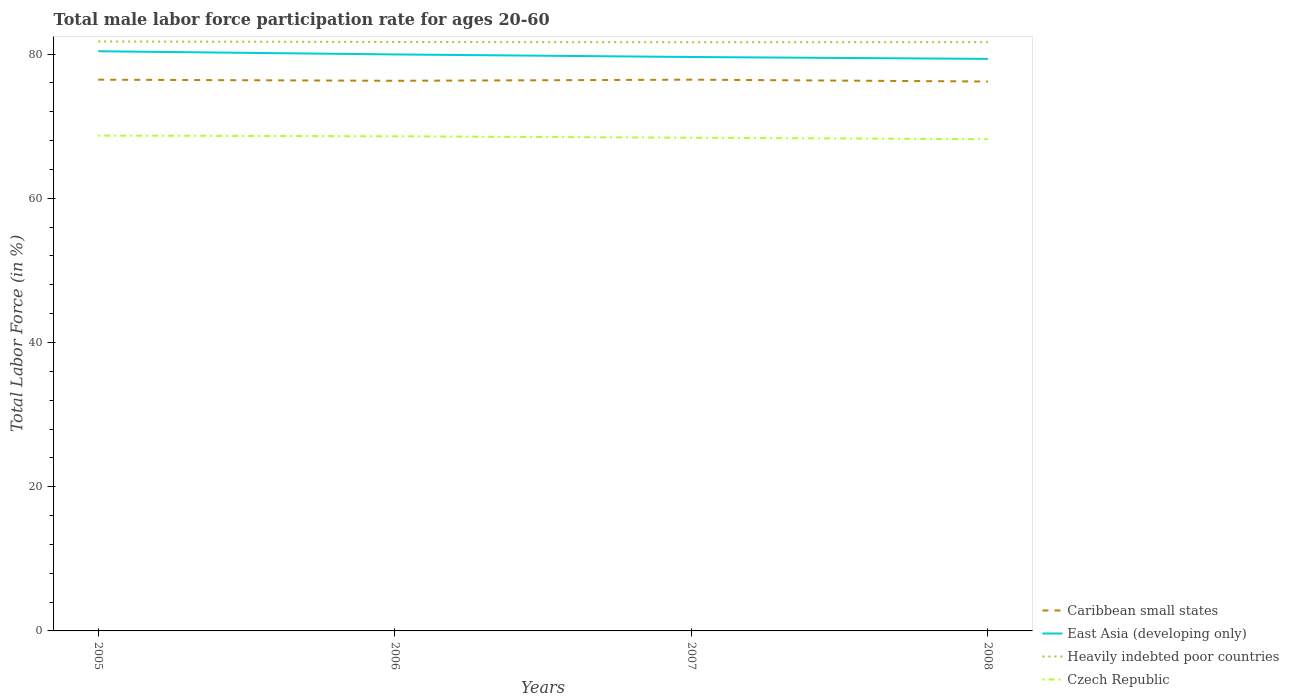How many different coloured lines are there?
Your answer should be compact. 4. Across all years, what is the maximum male labor force participation rate in Czech Republic?
Make the answer very short. 68.2. What is the total male labor force participation rate in Czech Republic in the graph?
Keep it short and to the point. 0.1. What is the difference between the highest and the second highest male labor force participation rate in Caribbean small states?
Offer a terse response. 0.25. Is the male labor force participation rate in Heavily indebted poor countries strictly greater than the male labor force participation rate in East Asia (developing only) over the years?
Ensure brevity in your answer.  No. How many years are there in the graph?
Give a very brief answer. 4. Does the graph contain grids?
Provide a succinct answer. No. Where does the legend appear in the graph?
Your answer should be very brief. Bottom right. What is the title of the graph?
Your response must be concise. Total male labor force participation rate for ages 20-60. What is the label or title of the X-axis?
Provide a succinct answer. Years. What is the label or title of the Y-axis?
Offer a very short reply. Total Labor Force (in %). What is the Total Labor Force (in %) of Caribbean small states in 2005?
Your answer should be compact. 76.45. What is the Total Labor Force (in %) in East Asia (developing only) in 2005?
Give a very brief answer. 80.39. What is the Total Labor Force (in %) in Heavily indebted poor countries in 2005?
Your response must be concise. 81.75. What is the Total Labor Force (in %) of Czech Republic in 2005?
Keep it short and to the point. 68.7. What is the Total Labor Force (in %) in Caribbean small states in 2006?
Your response must be concise. 76.3. What is the Total Labor Force (in %) in East Asia (developing only) in 2006?
Provide a succinct answer. 79.95. What is the Total Labor Force (in %) in Heavily indebted poor countries in 2006?
Your response must be concise. 81.68. What is the Total Labor Force (in %) of Czech Republic in 2006?
Your response must be concise. 68.6. What is the Total Labor Force (in %) of Caribbean small states in 2007?
Offer a very short reply. 76.45. What is the Total Labor Force (in %) of East Asia (developing only) in 2007?
Provide a succinct answer. 79.6. What is the Total Labor Force (in %) in Heavily indebted poor countries in 2007?
Provide a short and direct response. 81.65. What is the Total Labor Force (in %) of Czech Republic in 2007?
Your answer should be very brief. 68.4. What is the Total Labor Force (in %) of Caribbean small states in 2008?
Your answer should be compact. 76.2. What is the Total Labor Force (in %) of East Asia (developing only) in 2008?
Provide a succinct answer. 79.34. What is the Total Labor Force (in %) in Heavily indebted poor countries in 2008?
Provide a short and direct response. 81.66. What is the Total Labor Force (in %) in Czech Republic in 2008?
Offer a terse response. 68.2. Across all years, what is the maximum Total Labor Force (in %) of Caribbean small states?
Your response must be concise. 76.45. Across all years, what is the maximum Total Labor Force (in %) of East Asia (developing only)?
Keep it short and to the point. 80.39. Across all years, what is the maximum Total Labor Force (in %) in Heavily indebted poor countries?
Make the answer very short. 81.75. Across all years, what is the maximum Total Labor Force (in %) in Czech Republic?
Give a very brief answer. 68.7. Across all years, what is the minimum Total Labor Force (in %) of Caribbean small states?
Your answer should be compact. 76.2. Across all years, what is the minimum Total Labor Force (in %) of East Asia (developing only)?
Offer a very short reply. 79.34. Across all years, what is the minimum Total Labor Force (in %) of Heavily indebted poor countries?
Your response must be concise. 81.65. Across all years, what is the minimum Total Labor Force (in %) of Czech Republic?
Offer a very short reply. 68.2. What is the total Total Labor Force (in %) in Caribbean small states in the graph?
Your answer should be compact. 305.39. What is the total Total Labor Force (in %) of East Asia (developing only) in the graph?
Ensure brevity in your answer.  319.28. What is the total Total Labor Force (in %) of Heavily indebted poor countries in the graph?
Offer a terse response. 326.74. What is the total Total Labor Force (in %) in Czech Republic in the graph?
Keep it short and to the point. 273.9. What is the difference between the Total Labor Force (in %) in Caribbean small states in 2005 and that in 2006?
Give a very brief answer. 0.15. What is the difference between the Total Labor Force (in %) in East Asia (developing only) in 2005 and that in 2006?
Offer a very short reply. 0.44. What is the difference between the Total Labor Force (in %) in Heavily indebted poor countries in 2005 and that in 2006?
Keep it short and to the point. 0.07. What is the difference between the Total Labor Force (in %) of Czech Republic in 2005 and that in 2006?
Provide a succinct answer. 0.1. What is the difference between the Total Labor Force (in %) in Caribbean small states in 2005 and that in 2007?
Your answer should be very brief. -0. What is the difference between the Total Labor Force (in %) in East Asia (developing only) in 2005 and that in 2007?
Your answer should be compact. 0.8. What is the difference between the Total Labor Force (in %) of Heavily indebted poor countries in 2005 and that in 2007?
Your response must be concise. 0.1. What is the difference between the Total Labor Force (in %) of Czech Republic in 2005 and that in 2007?
Offer a terse response. 0.3. What is the difference between the Total Labor Force (in %) of Caribbean small states in 2005 and that in 2008?
Your response must be concise. 0.25. What is the difference between the Total Labor Force (in %) of East Asia (developing only) in 2005 and that in 2008?
Keep it short and to the point. 1.06. What is the difference between the Total Labor Force (in %) of Heavily indebted poor countries in 2005 and that in 2008?
Provide a short and direct response. 0.09. What is the difference between the Total Labor Force (in %) of Caribbean small states in 2006 and that in 2007?
Make the answer very short. -0.15. What is the difference between the Total Labor Force (in %) of East Asia (developing only) in 2006 and that in 2007?
Offer a very short reply. 0.36. What is the difference between the Total Labor Force (in %) of Heavily indebted poor countries in 2006 and that in 2007?
Your answer should be compact. 0.03. What is the difference between the Total Labor Force (in %) in Czech Republic in 2006 and that in 2007?
Provide a succinct answer. 0.2. What is the difference between the Total Labor Force (in %) of Caribbean small states in 2006 and that in 2008?
Provide a succinct answer. 0.1. What is the difference between the Total Labor Force (in %) in East Asia (developing only) in 2006 and that in 2008?
Offer a terse response. 0.62. What is the difference between the Total Labor Force (in %) of Heavily indebted poor countries in 2006 and that in 2008?
Provide a succinct answer. 0.01. What is the difference between the Total Labor Force (in %) of Czech Republic in 2006 and that in 2008?
Your response must be concise. 0.4. What is the difference between the Total Labor Force (in %) of Caribbean small states in 2007 and that in 2008?
Keep it short and to the point. 0.25. What is the difference between the Total Labor Force (in %) of East Asia (developing only) in 2007 and that in 2008?
Offer a very short reply. 0.26. What is the difference between the Total Labor Force (in %) of Heavily indebted poor countries in 2007 and that in 2008?
Keep it short and to the point. -0.02. What is the difference between the Total Labor Force (in %) of Caribbean small states in 2005 and the Total Labor Force (in %) of East Asia (developing only) in 2006?
Your response must be concise. -3.5. What is the difference between the Total Labor Force (in %) of Caribbean small states in 2005 and the Total Labor Force (in %) of Heavily indebted poor countries in 2006?
Your answer should be very brief. -5.23. What is the difference between the Total Labor Force (in %) of Caribbean small states in 2005 and the Total Labor Force (in %) of Czech Republic in 2006?
Ensure brevity in your answer.  7.85. What is the difference between the Total Labor Force (in %) of East Asia (developing only) in 2005 and the Total Labor Force (in %) of Heavily indebted poor countries in 2006?
Ensure brevity in your answer.  -1.28. What is the difference between the Total Labor Force (in %) in East Asia (developing only) in 2005 and the Total Labor Force (in %) in Czech Republic in 2006?
Provide a short and direct response. 11.79. What is the difference between the Total Labor Force (in %) in Heavily indebted poor countries in 2005 and the Total Labor Force (in %) in Czech Republic in 2006?
Your answer should be very brief. 13.15. What is the difference between the Total Labor Force (in %) of Caribbean small states in 2005 and the Total Labor Force (in %) of East Asia (developing only) in 2007?
Your answer should be compact. -3.15. What is the difference between the Total Labor Force (in %) of Caribbean small states in 2005 and the Total Labor Force (in %) of Heavily indebted poor countries in 2007?
Provide a succinct answer. -5.2. What is the difference between the Total Labor Force (in %) in Caribbean small states in 2005 and the Total Labor Force (in %) in Czech Republic in 2007?
Offer a terse response. 8.05. What is the difference between the Total Labor Force (in %) of East Asia (developing only) in 2005 and the Total Labor Force (in %) of Heavily indebted poor countries in 2007?
Offer a very short reply. -1.25. What is the difference between the Total Labor Force (in %) of East Asia (developing only) in 2005 and the Total Labor Force (in %) of Czech Republic in 2007?
Keep it short and to the point. 11.99. What is the difference between the Total Labor Force (in %) in Heavily indebted poor countries in 2005 and the Total Labor Force (in %) in Czech Republic in 2007?
Provide a short and direct response. 13.35. What is the difference between the Total Labor Force (in %) in Caribbean small states in 2005 and the Total Labor Force (in %) in East Asia (developing only) in 2008?
Your answer should be very brief. -2.89. What is the difference between the Total Labor Force (in %) in Caribbean small states in 2005 and the Total Labor Force (in %) in Heavily indebted poor countries in 2008?
Offer a very short reply. -5.21. What is the difference between the Total Labor Force (in %) in Caribbean small states in 2005 and the Total Labor Force (in %) in Czech Republic in 2008?
Offer a terse response. 8.25. What is the difference between the Total Labor Force (in %) in East Asia (developing only) in 2005 and the Total Labor Force (in %) in Heavily indebted poor countries in 2008?
Provide a succinct answer. -1.27. What is the difference between the Total Labor Force (in %) in East Asia (developing only) in 2005 and the Total Labor Force (in %) in Czech Republic in 2008?
Provide a short and direct response. 12.19. What is the difference between the Total Labor Force (in %) of Heavily indebted poor countries in 2005 and the Total Labor Force (in %) of Czech Republic in 2008?
Offer a terse response. 13.55. What is the difference between the Total Labor Force (in %) in Caribbean small states in 2006 and the Total Labor Force (in %) in East Asia (developing only) in 2007?
Make the answer very short. -3.3. What is the difference between the Total Labor Force (in %) of Caribbean small states in 2006 and the Total Labor Force (in %) of Heavily indebted poor countries in 2007?
Give a very brief answer. -5.35. What is the difference between the Total Labor Force (in %) in Caribbean small states in 2006 and the Total Labor Force (in %) in Czech Republic in 2007?
Ensure brevity in your answer.  7.9. What is the difference between the Total Labor Force (in %) in East Asia (developing only) in 2006 and the Total Labor Force (in %) in Heavily indebted poor countries in 2007?
Give a very brief answer. -1.7. What is the difference between the Total Labor Force (in %) in East Asia (developing only) in 2006 and the Total Labor Force (in %) in Czech Republic in 2007?
Give a very brief answer. 11.55. What is the difference between the Total Labor Force (in %) in Heavily indebted poor countries in 2006 and the Total Labor Force (in %) in Czech Republic in 2007?
Your answer should be compact. 13.28. What is the difference between the Total Labor Force (in %) in Caribbean small states in 2006 and the Total Labor Force (in %) in East Asia (developing only) in 2008?
Make the answer very short. -3.04. What is the difference between the Total Labor Force (in %) in Caribbean small states in 2006 and the Total Labor Force (in %) in Heavily indebted poor countries in 2008?
Your answer should be compact. -5.37. What is the difference between the Total Labor Force (in %) in Caribbean small states in 2006 and the Total Labor Force (in %) in Czech Republic in 2008?
Offer a very short reply. 8.1. What is the difference between the Total Labor Force (in %) of East Asia (developing only) in 2006 and the Total Labor Force (in %) of Heavily indebted poor countries in 2008?
Your answer should be very brief. -1.71. What is the difference between the Total Labor Force (in %) in East Asia (developing only) in 2006 and the Total Labor Force (in %) in Czech Republic in 2008?
Provide a short and direct response. 11.75. What is the difference between the Total Labor Force (in %) in Heavily indebted poor countries in 2006 and the Total Labor Force (in %) in Czech Republic in 2008?
Provide a short and direct response. 13.48. What is the difference between the Total Labor Force (in %) of Caribbean small states in 2007 and the Total Labor Force (in %) of East Asia (developing only) in 2008?
Make the answer very short. -2.88. What is the difference between the Total Labor Force (in %) in Caribbean small states in 2007 and the Total Labor Force (in %) in Heavily indebted poor countries in 2008?
Your response must be concise. -5.21. What is the difference between the Total Labor Force (in %) of Caribbean small states in 2007 and the Total Labor Force (in %) of Czech Republic in 2008?
Your answer should be very brief. 8.25. What is the difference between the Total Labor Force (in %) in East Asia (developing only) in 2007 and the Total Labor Force (in %) in Heavily indebted poor countries in 2008?
Make the answer very short. -2.07. What is the difference between the Total Labor Force (in %) of East Asia (developing only) in 2007 and the Total Labor Force (in %) of Czech Republic in 2008?
Your answer should be very brief. 11.4. What is the difference between the Total Labor Force (in %) of Heavily indebted poor countries in 2007 and the Total Labor Force (in %) of Czech Republic in 2008?
Your answer should be very brief. 13.45. What is the average Total Labor Force (in %) in Caribbean small states per year?
Ensure brevity in your answer.  76.35. What is the average Total Labor Force (in %) of East Asia (developing only) per year?
Your answer should be compact. 79.82. What is the average Total Labor Force (in %) of Heavily indebted poor countries per year?
Your response must be concise. 81.69. What is the average Total Labor Force (in %) in Czech Republic per year?
Provide a succinct answer. 68.47. In the year 2005, what is the difference between the Total Labor Force (in %) in Caribbean small states and Total Labor Force (in %) in East Asia (developing only)?
Offer a terse response. -3.94. In the year 2005, what is the difference between the Total Labor Force (in %) in Caribbean small states and Total Labor Force (in %) in Heavily indebted poor countries?
Your response must be concise. -5.3. In the year 2005, what is the difference between the Total Labor Force (in %) of Caribbean small states and Total Labor Force (in %) of Czech Republic?
Offer a terse response. 7.75. In the year 2005, what is the difference between the Total Labor Force (in %) in East Asia (developing only) and Total Labor Force (in %) in Heavily indebted poor countries?
Offer a very short reply. -1.36. In the year 2005, what is the difference between the Total Labor Force (in %) in East Asia (developing only) and Total Labor Force (in %) in Czech Republic?
Provide a short and direct response. 11.69. In the year 2005, what is the difference between the Total Labor Force (in %) of Heavily indebted poor countries and Total Labor Force (in %) of Czech Republic?
Your response must be concise. 13.05. In the year 2006, what is the difference between the Total Labor Force (in %) in Caribbean small states and Total Labor Force (in %) in East Asia (developing only)?
Give a very brief answer. -3.66. In the year 2006, what is the difference between the Total Labor Force (in %) in Caribbean small states and Total Labor Force (in %) in Heavily indebted poor countries?
Give a very brief answer. -5.38. In the year 2006, what is the difference between the Total Labor Force (in %) in Caribbean small states and Total Labor Force (in %) in Czech Republic?
Your answer should be compact. 7.7. In the year 2006, what is the difference between the Total Labor Force (in %) in East Asia (developing only) and Total Labor Force (in %) in Heavily indebted poor countries?
Your response must be concise. -1.72. In the year 2006, what is the difference between the Total Labor Force (in %) in East Asia (developing only) and Total Labor Force (in %) in Czech Republic?
Provide a succinct answer. 11.35. In the year 2006, what is the difference between the Total Labor Force (in %) of Heavily indebted poor countries and Total Labor Force (in %) of Czech Republic?
Keep it short and to the point. 13.08. In the year 2007, what is the difference between the Total Labor Force (in %) of Caribbean small states and Total Labor Force (in %) of East Asia (developing only)?
Offer a terse response. -3.15. In the year 2007, what is the difference between the Total Labor Force (in %) of Caribbean small states and Total Labor Force (in %) of Heavily indebted poor countries?
Your response must be concise. -5.2. In the year 2007, what is the difference between the Total Labor Force (in %) in Caribbean small states and Total Labor Force (in %) in Czech Republic?
Offer a very short reply. 8.05. In the year 2007, what is the difference between the Total Labor Force (in %) in East Asia (developing only) and Total Labor Force (in %) in Heavily indebted poor countries?
Offer a terse response. -2.05. In the year 2007, what is the difference between the Total Labor Force (in %) of East Asia (developing only) and Total Labor Force (in %) of Czech Republic?
Your answer should be compact. 11.2. In the year 2007, what is the difference between the Total Labor Force (in %) of Heavily indebted poor countries and Total Labor Force (in %) of Czech Republic?
Provide a succinct answer. 13.25. In the year 2008, what is the difference between the Total Labor Force (in %) in Caribbean small states and Total Labor Force (in %) in East Asia (developing only)?
Make the answer very short. -3.14. In the year 2008, what is the difference between the Total Labor Force (in %) in Caribbean small states and Total Labor Force (in %) in Heavily indebted poor countries?
Offer a very short reply. -5.47. In the year 2008, what is the difference between the Total Labor Force (in %) in Caribbean small states and Total Labor Force (in %) in Czech Republic?
Give a very brief answer. 8. In the year 2008, what is the difference between the Total Labor Force (in %) in East Asia (developing only) and Total Labor Force (in %) in Heavily indebted poor countries?
Your answer should be very brief. -2.33. In the year 2008, what is the difference between the Total Labor Force (in %) of East Asia (developing only) and Total Labor Force (in %) of Czech Republic?
Your answer should be compact. 11.14. In the year 2008, what is the difference between the Total Labor Force (in %) of Heavily indebted poor countries and Total Labor Force (in %) of Czech Republic?
Your answer should be compact. 13.46. What is the ratio of the Total Labor Force (in %) in East Asia (developing only) in 2005 to that in 2006?
Give a very brief answer. 1.01. What is the ratio of the Total Labor Force (in %) in Heavily indebted poor countries in 2005 to that in 2006?
Offer a terse response. 1. What is the ratio of the Total Labor Force (in %) in Caribbean small states in 2005 to that in 2007?
Make the answer very short. 1. What is the ratio of the Total Labor Force (in %) of East Asia (developing only) in 2005 to that in 2007?
Your answer should be compact. 1.01. What is the ratio of the Total Labor Force (in %) in Caribbean small states in 2005 to that in 2008?
Provide a succinct answer. 1. What is the ratio of the Total Labor Force (in %) of East Asia (developing only) in 2005 to that in 2008?
Provide a succinct answer. 1.01. What is the ratio of the Total Labor Force (in %) in Czech Republic in 2005 to that in 2008?
Make the answer very short. 1.01. What is the ratio of the Total Labor Force (in %) in Heavily indebted poor countries in 2006 to that in 2007?
Give a very brief answer. 1. What is the ratio of the Total Labor Force (in %) of Caribbean small states in 2006 to that in 2008?
Keep it short and to the point. 1. What is the ratio of the Total Labor Force (in %) in East Asia (developing only) in 2006 to that in 2008?
Provide a succinct answer. 1.01. What is the ratio of the Total Labor Force (in %) in Czech Republic in 2006 to that in 2008?
Give a very brief answer. 1.01. What is the ratio of the Total Labor Force (in %) in Caribbean small states in 2007 to that in 2008?
Your answer should be very brief. 1. What is the ratio of the Total Labor Force (in %) of Heavily indebted poor countries in 2007 to that in 2008?
Provide a succinct answer. 1. What is the ratio of the Total Labor Force (in %) of Czech Republic in 2007 to that in 2008?
Keep it short and to the point. 1. What is the difference between the highest and the second highest Total Labor Force (in %) in Caribbean small states?
Keep it short and to the point. 0. What is the difference between the highest and the second highest Total Labor Force (in %) of East Asia (developing only)?
Offer a very short reply. 0.44. What is the difference between the highest and the second highest Total Labor Force (in %) in Heavily indebted poor countries?
Make the answer very short. 0.07. What is the difference between the highest and the second highest Total Labor Force (in %) of Czech Republic?
Provide a short and direct response. 0.1. What is the difference between the highest and the lowest Total Labor Force (in %) of Caribbean small states?
Offer a terse response. 0.25. What is the difference between the highest and the lowest Total Labor Force (in %) in East Asia (developing only)?
Offer a very short reply. 1.06. What is the difference between the highest and the lowest Total Labor Force (in %) in Heavily indebted poor countries?
Your answer should be compact. 0.1. 